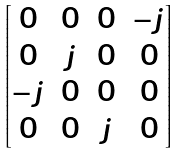Convert formula to latex. <formula><loc_0><loc_0><loc_500><loc_500>\begin{bmatrix} 0 & 0 & 0 & - j \\ 0 & j & 0 & 0 \\ - j & 0 & 0 & 0 \\ 0 & 0 & j & 0 \end{bmatrix}</formula> 